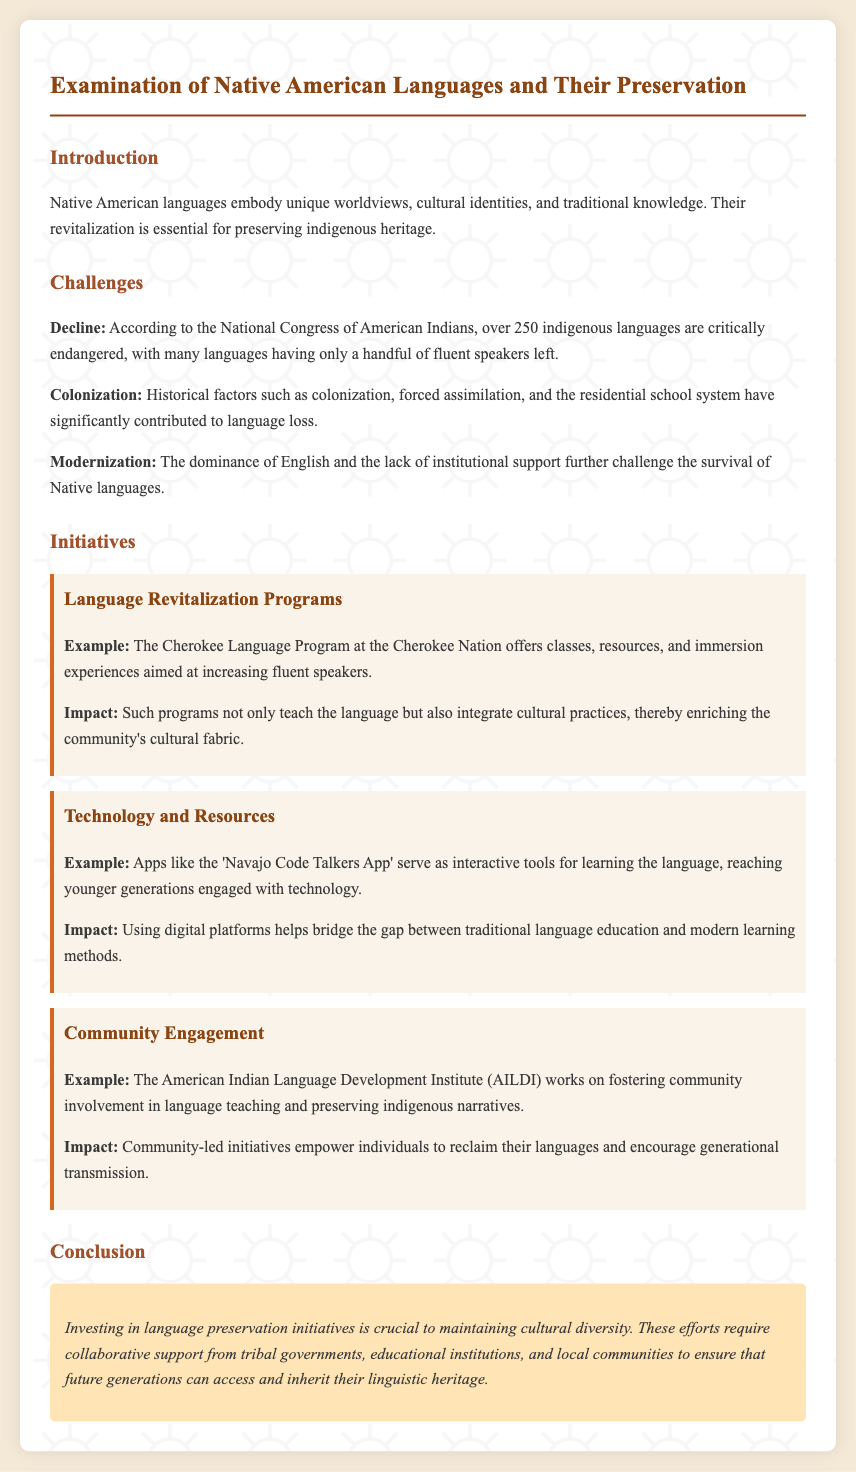What is the title of the memo? The title of the memo is stated at the beginning, indicating the main subject of discussion.
Answer: Examination of Native American Languages and Their Preservation How many indigenous languages are critically endangered? The document references a statistic provided by the National Congress of American Indians, indicating the number of critically endangered languages.
Answer: Over 250 What organization offers the Cherokee Language Program? The memo mentions a specific organization that is responsible for offering a language program geared towards revitalization efforts.
Answer: Cherokee Nation What is an example of a technology initiative mentioned? The document lists a specific app as an example of how technology is utilized for language learning.
Answer: Navajo Code Talkers App What impact do language revitalization programs have? The memo describes the broader effect of these programs on the community and cultural practices.
Answer: Enriching the community's cultural fabric What is required for successful language preservation initiatives? The conclusion highlights a need that is crucial for the effectiveness of these initiatives going forward.
Answer: Collaborative support 